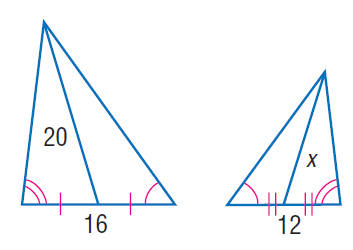Question: Find x.
Choices:
A. 10
B. 12
C. 15
D. 16
Answer with the letter. Answer: C 